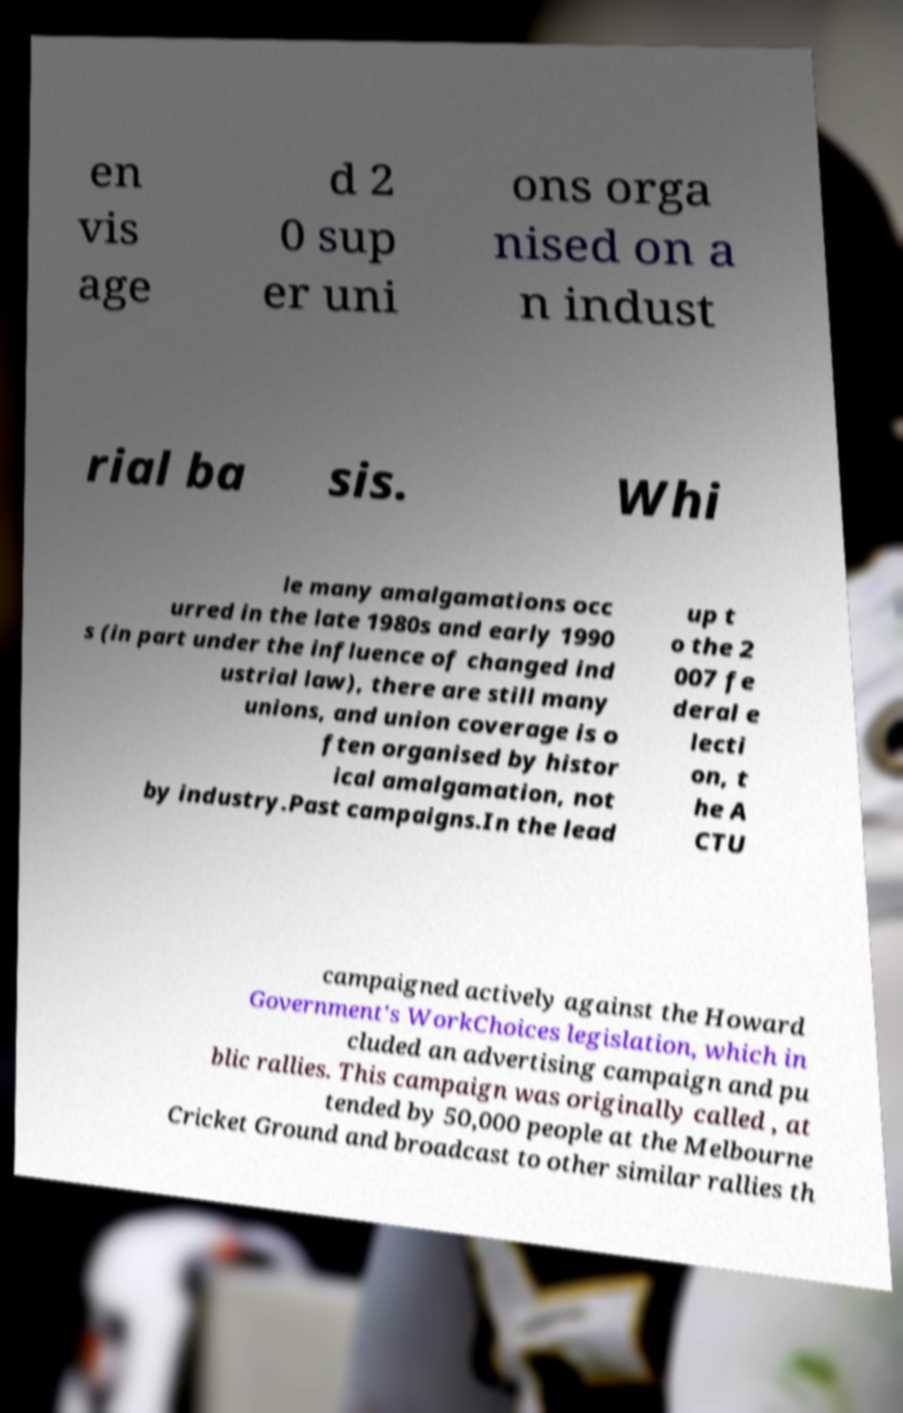Could you assist in decoding the text presented in this image and type it out clearly? en vis age d 2 0 sup er uni ons orga nised on a n indust rial ba sis. Whi le many amalgamations occ urred in the late 1980s and early 1990 s (in part under the influence of changed ind ustrial law), there are still many unions, and union coverage is o ften organised by histor ical amalgamation, not by industry.Past campaigns.In the lead up t o the 2 007 fe deral e lecti on, t he A CTU campaigned actively against the Howard Government's WorkChoices legislation, which in cluded an advertising campaign and pu blic rallies. This campaign was originally called , at tended by 50,000 people at the Melbourne Cricket Ground and broadcast to other similar rallies th 